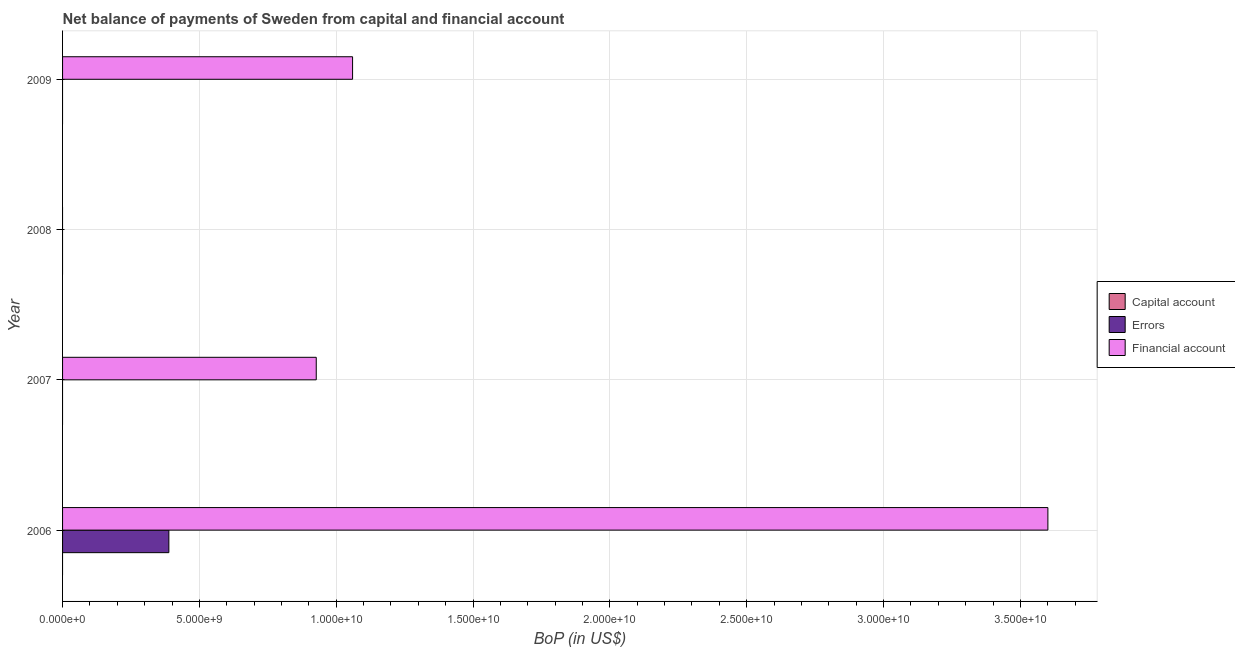How many bars are there on the 2nd tick from the top?
Ensure brevity in your answer.  0. How many bars are there on the 3rd tick from the bottom?
Your response must be concise. 0. What is the amount of net capital account in 2006?
Your answer should be compact. 0. Across all years, what is the maximum amount of errors?
Ensure brevity in your answer.  3.88e+09. What is the difference between the amount of financial account in 2006 and that in 2007?
Offer a very short reply. 2.67e+1. What is the average amount of net capital account per year?
Offer a very short reply. 0. In how many years, is the amount of net capital account greater than 22000000000 US$?
Provide a succinct answer. 0. What is the difference between the highest and the second highest amount of financial account?
Offer a very short reply. 2.54e+1. What is the difference between the highest and the lowest amount of financial account?
Give a very brief answer. 3.60e+1. Is the sum of the amount of financial account in 2006 and 2007 greater than the maximum amount of errors across all years?
Offer a very short reply. Yes. Is it the case that in every year, the sum of the amount of net capital account and amount of errors is greater than the amount of financial account?
Give a very brief answer. No. Are all the bars in the graph horizontal?
Provide a succinct answer. Yes. How many years are there in the graph?
Offer a very short reply. 4. Are the values on the major ticks of X-axis written in scientific E-notation?
Your answer should be very brief. Yes. Does the graph contain any zero values?
Ensure brevity in your answer.  Yes. Where does the legend appear in the graph?
Keep it short and to the point. Center right. How are the legend labels stacked?
Make the answer very short. Vertical. What is the title of the graph?
Offer a terse response. Net balance of payments of Sweden from capital and financial account. Does "Transport services" appear as one of the legend labels in the graph?
Make the answer very short. No. What is the label or title of the X-axis?
Offer a very short reply. BoP (in US$). What is the BoP (in US$) in Errors in 2006?
Your response must be concise. 3.88e+09. What is the BoP (in US$) in Financial account in 2006?
Offer a very short reply. 3.60e+1. What is the BoP (in US$) of Capital account in 2007?
Provide a succinct answer. 0. What is the BoP (in US$) in Financial account in 2007?
Give a very brief answer. 9.27e+09. What is the BoP (in US$) of Capital account in 2008?
Make the answer very short. 0. What is the BoP (in US$) of Errors in 2008?
Keep it short and to the point. 0. What is the BoP (in US$) of Capital account in 2009?
Your answer should be compact. 0. What is the BoP (in US$) of Financial account in 2009?
Keep it short and to the point. 1.06e+1. Across all years, what is the maximum BoP (in US$) of Errors?
Provide a succinct answer. 3.88e+09. Across all years, what is the maximum BoP (in US$) of Financial account?
Keep it short and to the point. 3.60e+1. What is the total BoP (in US$) of Errors in the graph?
Offer a terse response. 3.88e+09. What is the total BoP (in US$) in Financial account in the graph?
Ensure brevity in your answer.  5.59e+1. What is the difference between the BoP (in US$) of Financial account in 2006 and that in 2007?
Provide a succinct answer. 2.67e+1. What is the difference between the BoP (in US$) of Financial account in 2006 and that in 2009?
Your answer should be compact. 2.54e+1. What is the difference between the BoP (in US$) of Financial account in 2007 and that in 2009?
Make the answer very short. -1.33e+09. What is the difference between the BoP (in US$) of Errors in 2006 and the BoP (in US$) of Financial account in 2007?
Make the answer very short. -5.39e+09. What is the difference between the BoP (in US$) of Errors in 2006 and the BoP (in US$) of Financial account in 2009?
Offer a terse response. -6.71e+09. What is the average BoP (in US$) of Capital account per year?
Provide a succinct answer. 0. What is the average BoP (in US$) in Errors per year?
Provide a short and direct response. 9.71e+08. What is the average BoP (in US$) of Financial account per year?
Offer a very short reply. 1.40e+1. In the year 2006, what is the difference between the BoP (in US$) in Errors and BoP (in US$) in Financial account?
Ensure brevity in your answer.  -3.21e+1. What is the ratio of the BoP (in US$) of Financial account in 2006 to that in 2007?
Your answer should be very brief. 3.88. What is the ratio of the BoP (in US$) in Financial account in 2006 to that in 2009?
Your answer should be very brief. 3.4. What is the ratio of the BoP (in US$) of Financial account in 2007 to that in 2009?
Make the answer very short. 0.87. What is the difference between the highest and the second highest BoP (in US$) of Financial account?
Ensure brevity in your answer.  2.54e+1. What is the difference between the highest and the lowest BoP (in US$) in Errors?
Offer a terse response. 3.88e+09. What is the difference between the highest and the lowest BoP (in US$) of Financial account?
Make the answer very short. 3.60e+1. 